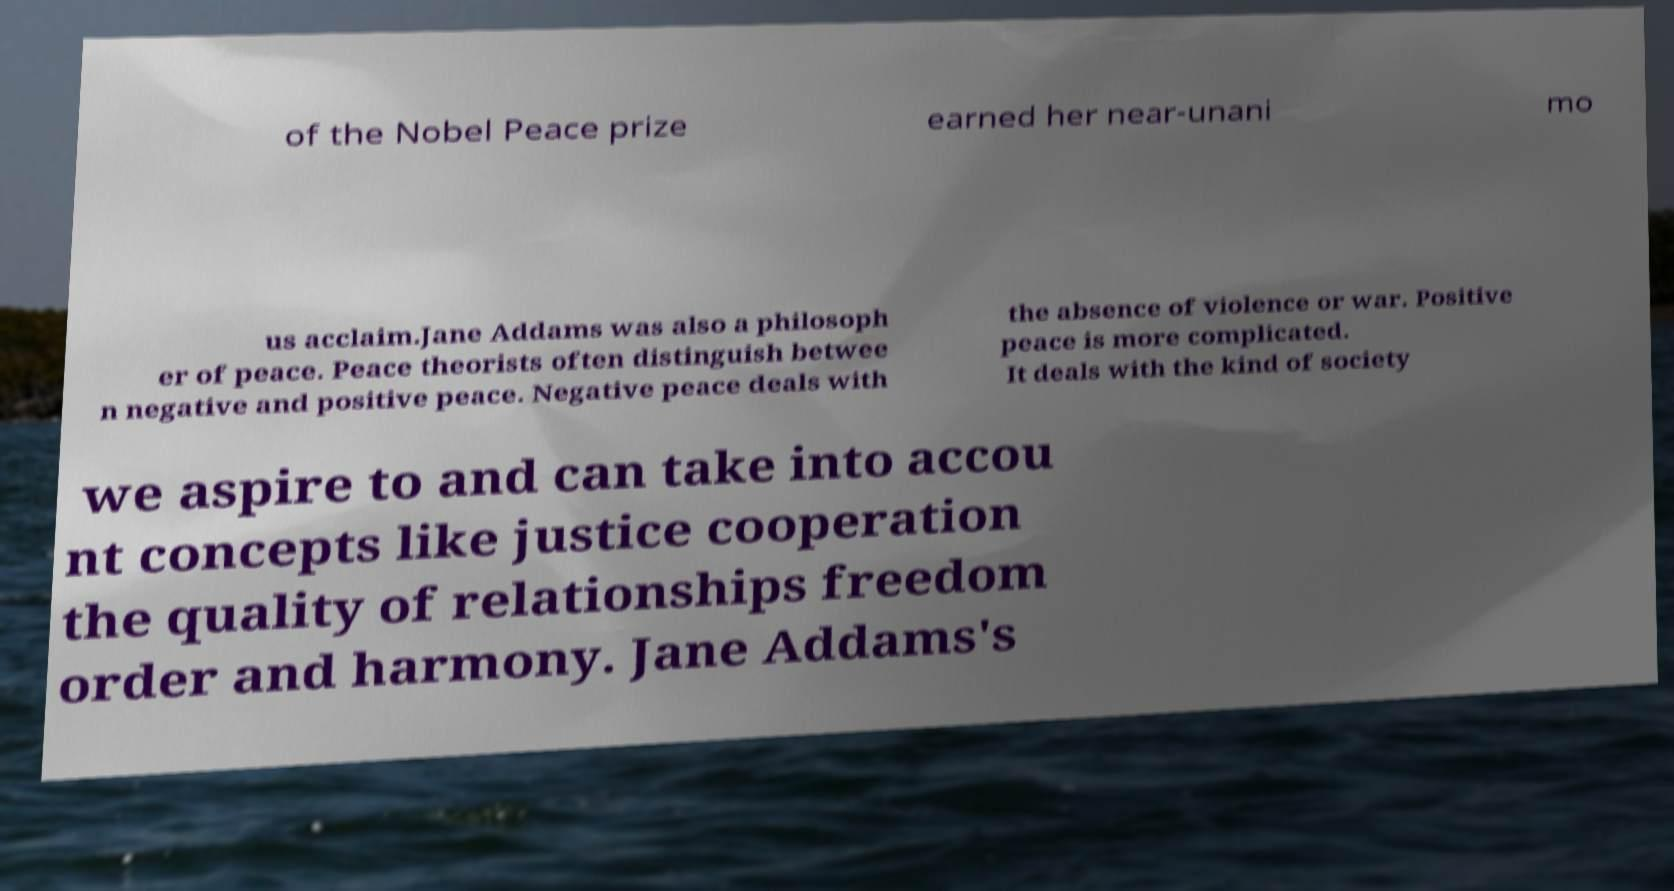For documentation purposes, I need the text within this image transcribed. Could you provide that? of the Nobel Peace prize earned her near-unani mo us acclaim.Jane Addams was also a philosoph er of peace. Peace theorists often distinguish betwee n negative and positive peace. Negative peace deals with the absence of violence or war. Positive peace is more complicated. It deals with the kind of society we aspire to and can take into accou nt concepts like justice cooperation the quality of relationships freedom order and harmony. Jane Addams's 